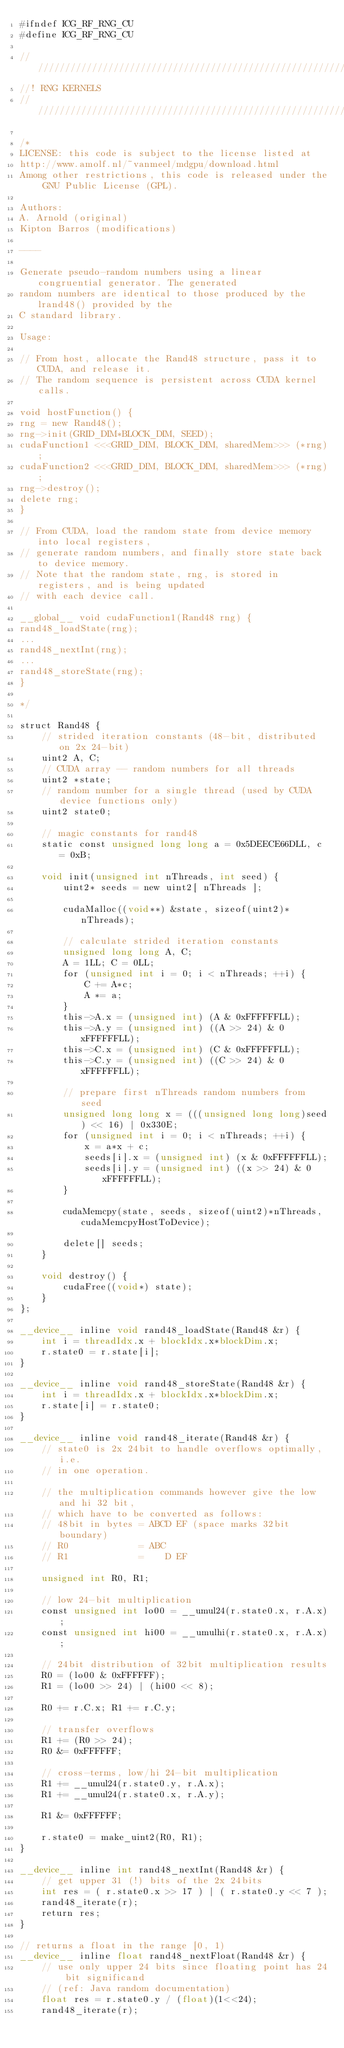Convert code to text. <code><loc_0><loc_0><loc_500><loc_500><_Cuda_>#ifndef ICG_RF_RNG_CU
#define ICG_RF_RNG_CU

///////////////////////////////////////////////////////////////////////////////
//! RNG KERNELS
////////////////////////////////////////////////////////////////////////////////

/*
LICENSE: this code is subject to the license listed at
http://www.amolf.nl/~vanmeel/mdgpu/download.html
Among other restrictions, this code is released under the GNU Public License (GPL).

Authors:
A. Arnold (original)
Kipton Barros (modifications)

----

Generate pseudo-random numbers using a linear congruential generator. The generated
random numbers are identical to those produced by the lrand48() provided by the
C standard library.

Usage:

// From host, allocate the Rand48 structure, pass it to CUDA, and release it.
// The random sequence is persistent across CUDA kernel calls.

void hostFunction() {
rng = new Rand48();
rng->init(GRID_DIM*BLOCK_DIM, SEED);
cudaFunction1 <<<GRID_DIM, BLOCK_DIM, sharedMem>>> (*rng);
cudaFunction2 <<<GRID_DIM, BLOCK_DIM, sharedMem>>> (*rng);
rng->destroy();
delete rng;
}

// From CUDA, load the random state from device memory into local registers,
// generate random numbers, and finally store state back to device memory.
// Note that the random state, rng, is stored in registers, and is being updated
// with each device call.

__global__ void cudaFunction1(Rand48 rng) {
rand48_loadState(rng);
...
rand48_nextInt(rng);
...
rand48_storeState(rng);
}

*/

struct Rand48 {
    // strided iteration constants (48-bit, distributed on 2x 24-bit)
    uint2 A, C;
    // CUDA array -- random numbers for all threads
    uint2 *state;
    // random number for a single thread (used by CUDA device functions only)
    uint2 state0;

    // magic constants for rand48
    static const unsigned long long a = 0x5DEECE66DLL, c = 0xB;

    void init(unsigned int nThreads, int seed) {
        uint2* seeds = new uint2[ nThreads ];

        cudaMalloc((void**) &state, sizeof(uint2)*nThreads);

        // calculate strided iteration constants
        unsigned long long A, C;
        A = 1LL; C = 0LL;
        for (unsigned int i = 0; i < nThreads; ++i) {
            C += A*c;
            A *= a;
        }
        this->A.x = (unsigned int) (A & 0xFFFFFFLL);
        this->A.y = (unsigned int) ((A >> 24) & 0xFFFFFFLL);
        this->C.x = (unsigned int) (C & 0xFFFFFFLL);
        this->C.y = (unsigned int) ((C >> 24) & 0xFFFFFFLL);

        // prepare first nThreads random numbers from seed
        unsigned long long x = (((unsigned long long)seed) << 16) | 0x330E;
        for (unsigned int i = 0; i < nThreads; ++i) {
            x = a*x + c;
            seeds[i].x = (unsigned int) (x & 0xFFFFFFLL);
            seeds[i].y = (unsigned int) ((x >> 24) & 0xFFFFFFLL);
        }

        cudaMemcpy(state, seeds, sizeof(uint2)*nThreads, cudaMemcpyHostToDevice);

        delete[] seeds;
    }

    void destroy() {
        cudaFree((void*) state);
    }
};

__device__ inline void rand48_loadState(Rand48 &r) {
    int i = threadIdx.x + blockIdx.x*blockDim.x;
    r.state0 = r.state[i];
}

__device__ inline void rand48_storeState(Rand48 &r) {
    int i = threadIdx.x + blockIdx.x*blockDim.x;
    r.state[i] = r.state0;
}

__device__ inline void rand48_iterate(Rand48 &r) {
    // state0 is 2x 24bit to handle overflows optimally, i.e.
    // in one operation.

    // the multiplication commands however give the low and hi 32 bit,
    // which have to be converted as follows:
    // 48bit in bytes = ABCD EF (space marks 32bit boundary)
    // R0             = ABC
    // R1             =    D EF

    unsigned int R0, R1;

    // low 24-bit multiplication
    const unsigned int lo00 = __umul24(r.state0.x, r.A.x);
    const unsigned int hi00 = __umulhi(r.state0.x, r.A.x);

    // 24bit distribution of 32bit multiplication results
    R0 = (lo00 & 0xFFFFFF);
    R1 = (lo00 >> 24) | (hi00 << 8);

    R0 += r.C.x; R1 += r.C.y;

    // transfer overflows
    R1 += (R0 >> 24);
    R0 &= 0xFFFFFF;

    // cross-terms, low/hi 24-bit multiplication
    R1 += __umul24(r.state0.y, r.A.x);
    R1 += __umul24(r.state0.x, r.A.y);

    R1 &= 0xFFFFFF;

    r.state0 = make_uint2(R0, R1);
}

__device__ inline int rand48_nextInt(Rand48 &r) {
    // get upper 31 (!) bits of the 2x 24bits
    int res = ( r.state0.x >> 17 ) | ( r.state0.y << 7 );
    rand48_iterate(r);
    return res;
}

// returns a float in the range [0, 1)
__device__ inline float rand48_nextFloat(Rand48 &r) {
    // use only upper 24 bits since floating point has 24 bit significand
    // (ref: Java random documentation)
    float res = r.state0.y / (float)(1<<24);
    rand48_iterate(r);</code> 